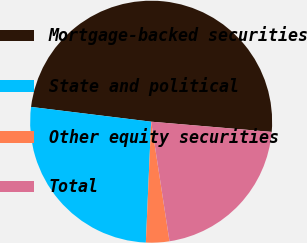Convert chart to OTSL. <chart><loc_0><loc_0><loc_500><loc_500><pie_chart><fcel>Mortgage-backed securities<fcel>State and political<fcel>Other equity securities<fcel>Total<nl><fcel>49.4%<fcel>26.25%<fcel>3.12%<fcel>21.23%<nl></chart> 